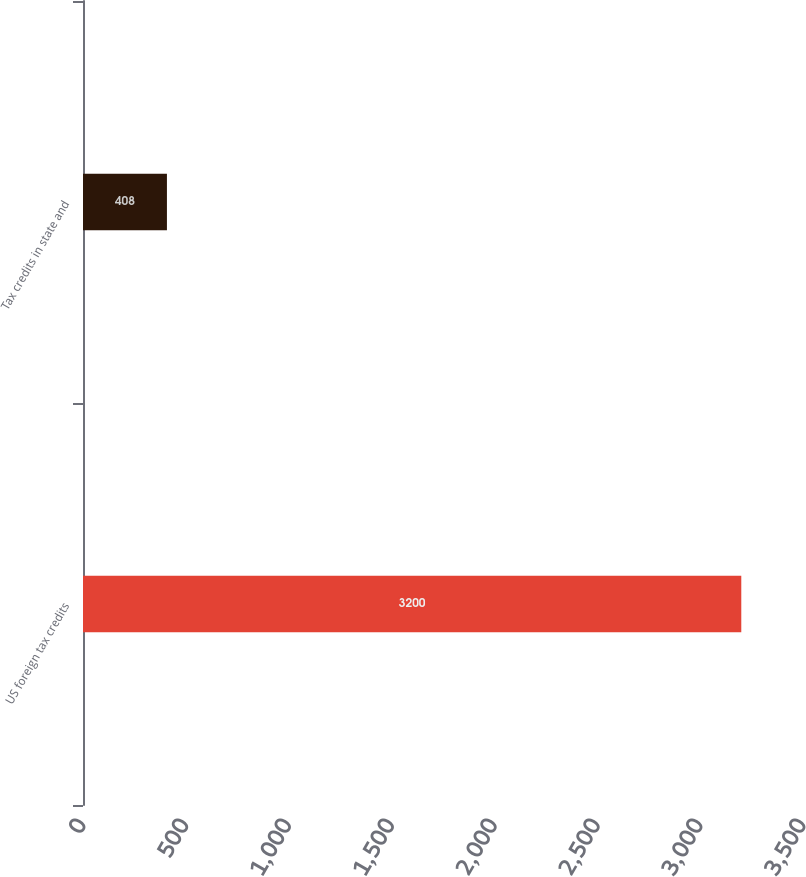Convert chart to OTSL. <chart><loc_0><loc_0><loc_500><loc_500><bar_chart><fcel>US foreign tax credits<fcel>Tax credits in state and<nl><fcel>3200<fcel>408<nl></chart> 